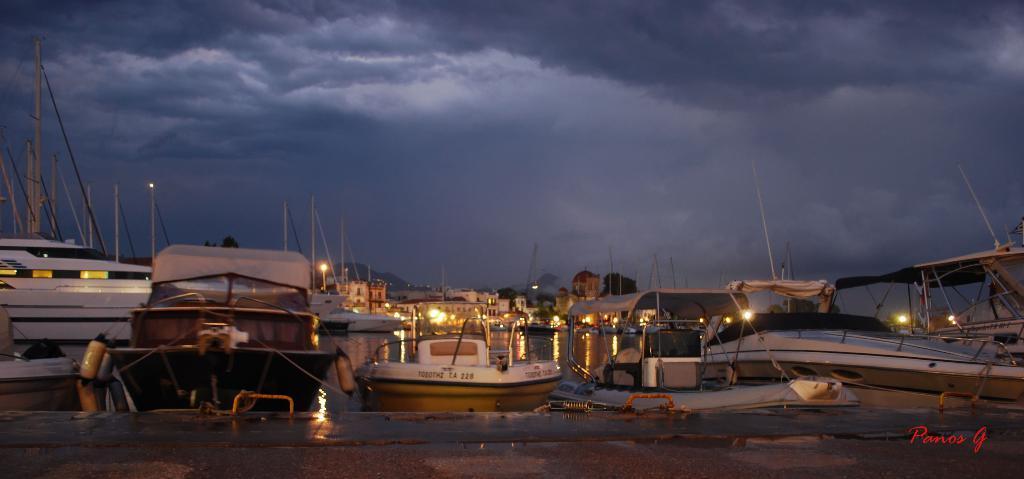Can you describe this image briefly? In the picture I can see boats, poles, lights and some other objects. In the background I can see the sky. On the bottom right corner of the image I can see a watermark. 